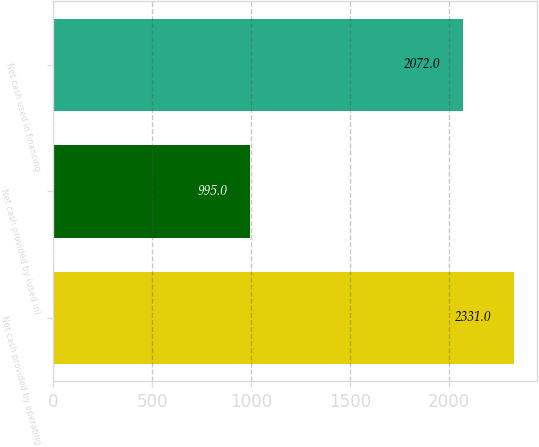Convert chart to OTSL. <chart><loc_0><loc_0><loc_500><loc_500><bar_chart><fcel>Net cash provided by operating<fcel>Net cash provided by (used in)<fcel>Net cash used in financing<nl><fcel>2331<fcel>995<fcel>2072<nl></chart> 